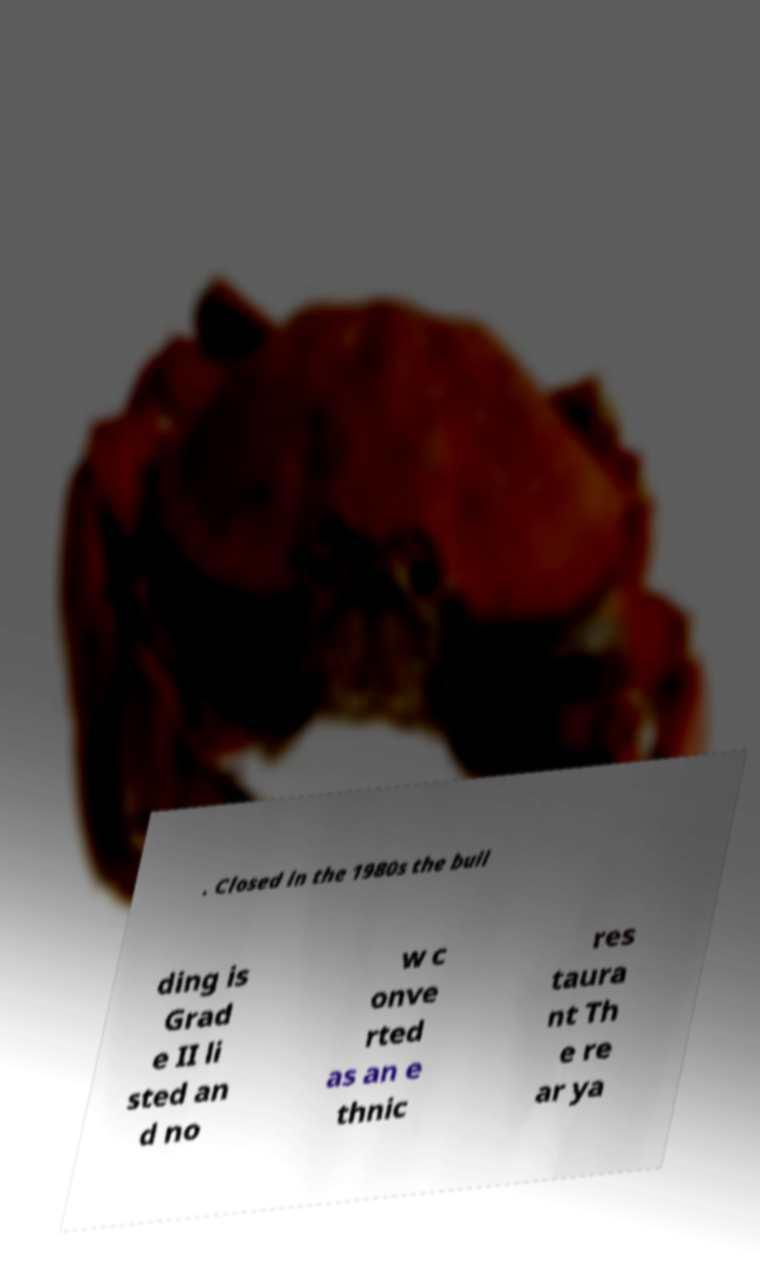Could you assist in decoding the text presented in this image and type it out clearly? . Closed in the 1980s the buil ding is Grad e II li sted an d no w c onve rted as an e thnic res taura nt Th e re ar ya 